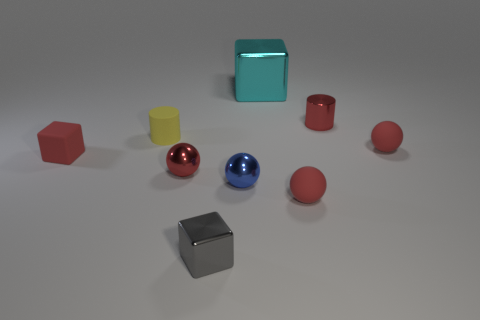How many red spheres must be subtracted to get 1 red spheres? 2 Subtract all yellow cylinders. How many red spheres are left? 3 Subtract 1 balls. How many balls are left? 3 Add 1 blue rubber things. How many objects exist? 10 Subtract all cubes. How many objects are left? 6 Add 6 tiny cubes. How many tiny cubes are left? 8 Add 1 spheres. How many spheres exist? 5 Subtract 0 gray cylinders. How many objects are left? 9 Subtract all large purple rubber cubes. Subtract all large cubes. How many objects are left? 8 